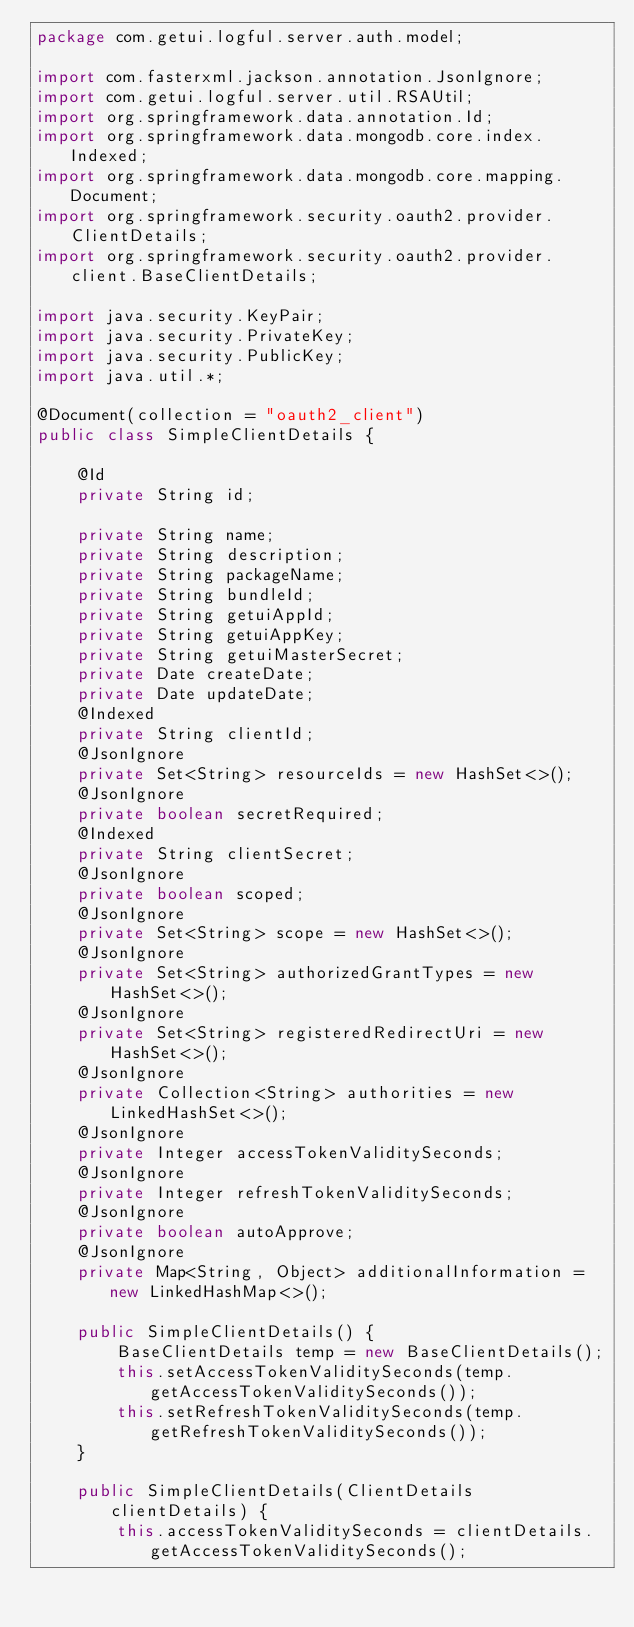Convert code to text. <code><loc_0><loc_0><loc_500><loc_500><_Java_>package com.getui.logful.server.auth.model;

import com.fasterxml.jackson.annotation.JsonIgnore;
import com.getui.logful.server.util.RSAUtil;
import org.springframework.data.annotation.Id;
import org.springframework.data.mongodb.core.index.Indexed;
import org.springframework.data.mongodb.core.mapping.Document;
import org.springframework.security.oauth2.provider.ClientDetails;
import org.springframework.security.oauth2.provider.client.BaseClientDetails;

import java.security.KeyPair;
import java.security.PrivateKey;
import java.security.PublicKey;
import java.util.*;

@Document(collection = "oauth2_client")
public class SimpleClientDetails {

    @Id
    private String id;

    private String name;
    private String description;
    private String packageName;
    private String bundleId;
    private String getuiAppId;
    private String getuiAppKey;
    private String getuiMasterSecret;
    private Date createDate;
    private Date updateDate;
    @Indexed
    private String clientId;
    @JsonIgnore
    private Set<String> resourceIds = new HashSet<>();
    @JsonIgnore
    private boolean secretRequired;
    @Indexed
    private String clientSecret;
    @JsonIgnore
    private boolean scoped;
    @JsonIgnore
    private Set<String> scope = new HashSet<>();
    @JsonIgnore
    private Set<String> authorizedGrantTypes = new HashSet<>();
    @JsonIgnore
    private Set<String> registeredRedirectUri = new HashSet<>();
    @JsonIgnore
    private Collection<String> authorities = new LinkedHashSet<>();
    @JsonIgnore
    private Integer accessTokenValiditySeconds;
    @JsonIgnore
    private Integer refreshTokenValiditySeconds;
    @JsonIgnore
    private boolean autoApprove;
    @JsonIgnore
    private Map<String, Object> additionalInformation = new LinkedHashMap<>();

    public SimpleClientDetails() {
        BaseClientDetails temp = new BaseClientDetails();
        this.setAccessTokenValiditySeconds(temp.getAccessTokenValiditySeconds());
        this.setRefreshTokenValiditySeconds(temp.getRefreshTokenValiditySeconds());
    }

    public SimpleClientDetails(ClientDetails clientDetails) {
        this.accessTokenValiditySeconds = clientDetails.getAccessTokenValiditySeconds();</code> 